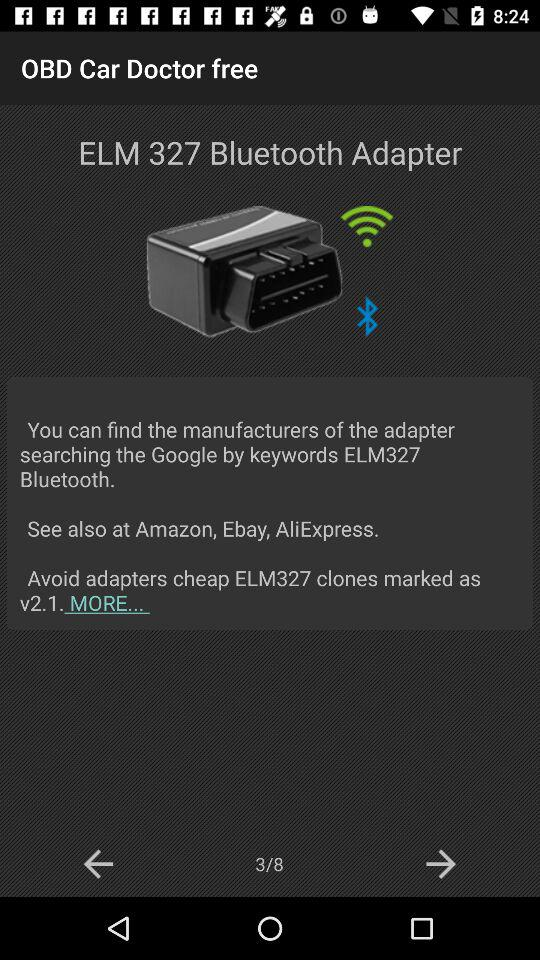What is the model number of the Bluetooth adapter? The model number of the Bluetooth adapter is "ELM 327". 